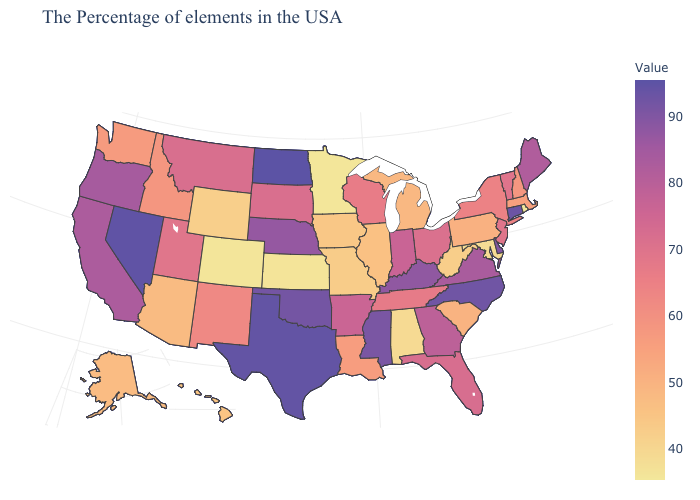Is the legend a continuous bar?
Concise answer only. Yes. Does North Dakota have the highest value in the MidWest?
Answer briefly. Yes. Does New Jersey have the highest value in the Northeast?
Short answer required. No. Is the legend a continuous bar?
Answer briefly. Yes. Does North Dakota have the highest value in the MidWest?
Keep it brief. Yes. Which states have the highest value in the USA?
Short answer required. North Dakota. Does North Dakota have the highest value in the MidWest?
Give a very brief answer. Yes. Which states have the lowest value in the West?
Concise answer only. Colorado. 